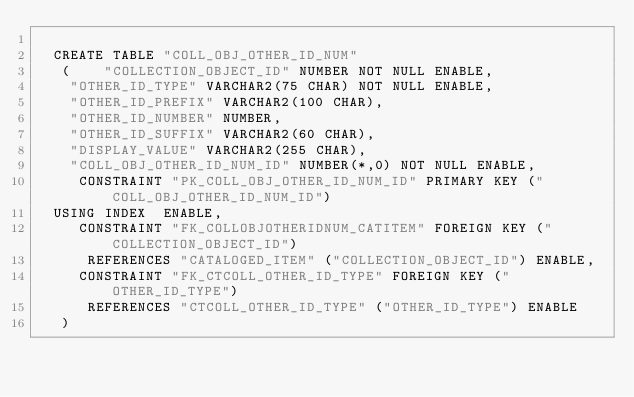<code> <loc_0><loc_0><loc_500><loc_500><_SQL_>
  CREATE TABLE "COLL_OBJ_OTHER_ID_NUM" 
   (	"COLLECTION_OBJECT_ID" NUMBER NOT NULL ENABLE, 
	"OTHER_ID_TYPE" VARCHAR2(75 CHAR) NOT NULL ENABLE, 
	"OTHER_ID_PREFIX" VARCHAR2(100 CHAR), 
	"OTHER_ID_NUMBER" NUMBER, 
	"OTHER_ID_SUFFIX" VARCHAR2(60 CHAR), 
	"DISPLAY_VALUE" VARCHAR2(255 CHAR), 
	"COLL_OBJ_OTHER_ID_NUM_ID" NUMBER(*,0) NOT NULL ENABLE, 
	 CONSTRAINT "PK_COLL_OBJ_OTHER_ID_NUM_ID" PRIMARY KEY ("COLL_OBJ_OTHER_ID_NUM_ID")
  USING INDEX  ENABLE, 
	 CONSTRAINT "FK_COLLOBJOTHERIDNUM_CATITEM" FOREIGN KEY ("COLLECTION_OBJECT_ID")
	  REFERENCES "CATALOGED_ITEM" ("COLLECTION_OBJECT_ID") ENABLE, 
	 CONSTRAINT "FK_CTCOLL_OTHER_ID_TYPE" FOREIGN KEY ("OTHER_ID_TYPE")
	  REFERENCES "CTCOLL_OTHER_ID_TYPE" ("OTHER_ID_TYPE") ENABLE
   ) </code> 